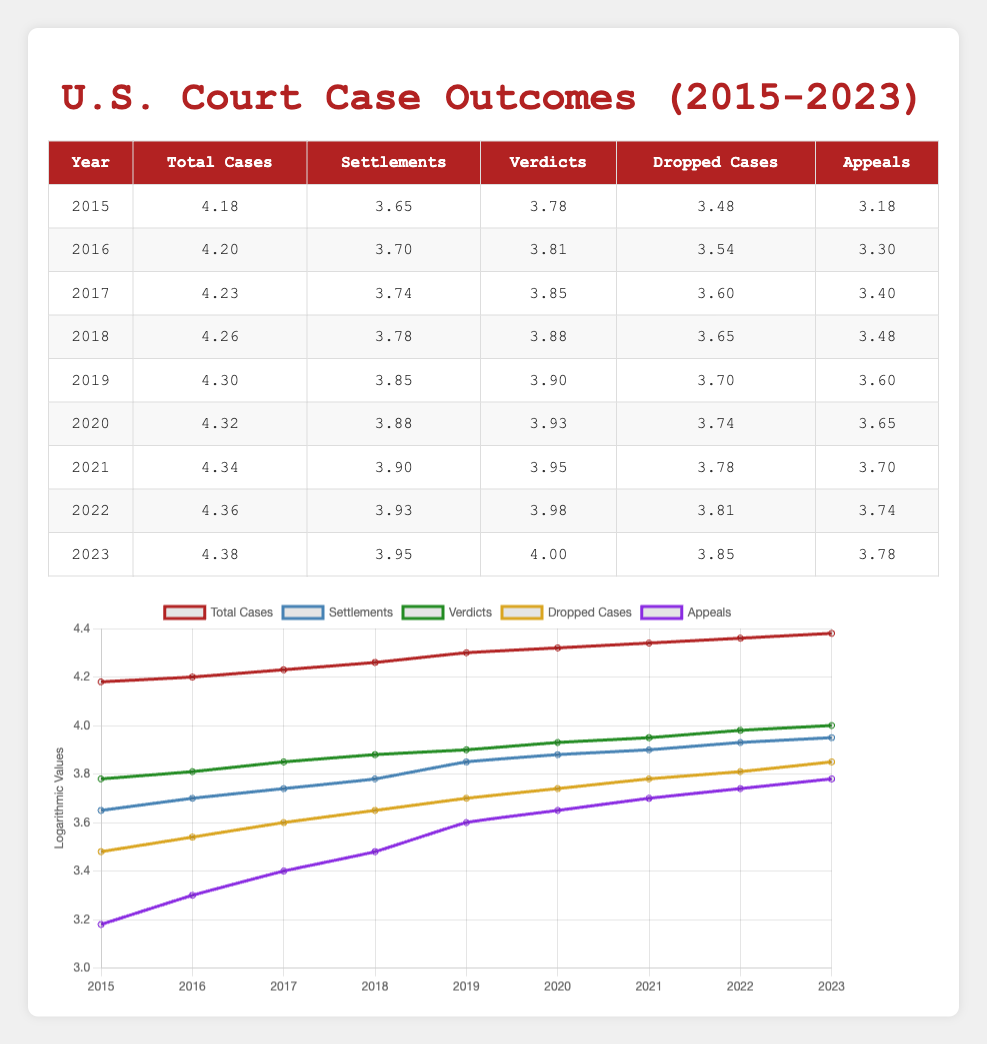What was the total number of cases in 2019? The total cases for 2019 are listed in the table, which is under the "Total Cases" column for that year. The value is 20000.
Answer: 20000 Which year had the highest number of dropped cases? To answer this, I look through the "Dropped Cases" column for each year. The highest number is 7000, which corresponds to the year 2023.
Answer: 2023 What is the total number of settlements from 2015 to 2023? To find the total settlements from 2015 to 2023, I need to add the settlements for each year: 4500 + 5000 + 5500 + 6000 + 7000 + 7500 + 8000 + 8500 + 9000 = 51500.
Answer: 51500 Did the number of verdicts increase every year from 2015 to 2023? By reviewing the "Verdicts" column, I can see the values for each year: 6000, 6500, 7000, 7500, 8000, 8500, 9000, 9500, 10000. Since each subsequent year shows a higher number than the previous year, the answer is yes.
Answer: Yes What is the average number of appeals per year from 2015 to 2023? The total number of appeals from 2015 to 2023 is 1500 + 2000 + 2500 + 3000 + 4000 + 4500 + 5000 + 5500 + 6000 = 29500. There are 9 years, so the average is 29500 / 9 ≈ 3277.78.
Answer: 3277.78 In which year was the difference between dropped cases and verdicts the greatest? I need to calculate the difference for each year by subtracting the "Dropped Cases" from "Verdicts": 6000-3000=3000, 6500-3500=3000, 7000-4000=3000 and so forth. The differences are consistently 3000 until 2023 where it is 10000-7000=3000. Since differences remain the same, there is no greatest year.
Answer: No greatest year What is the percentage increase in total cases from 2015 to 2023? The total cases in 2015 are 15000 and in 2023 are 24000. The increase is 24000 - 15000 = 9000. The percentage increase is (9000 / 15000) * 100 = 60%.
Answer: 60% 